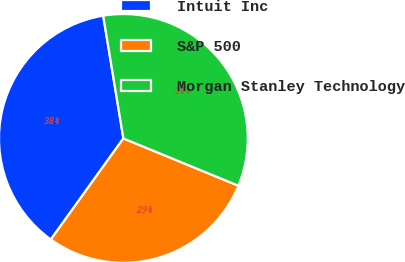<chart> <loc_0><loc_0><loc_500><loc_500><pie_chart><fcel>Intuit Inc<fcel>S&P 500<fcel>Morgan Stanley Technology<nl><fcel>37.5%<fcel>28.7%<fcel>33.8%<nl></chart> 